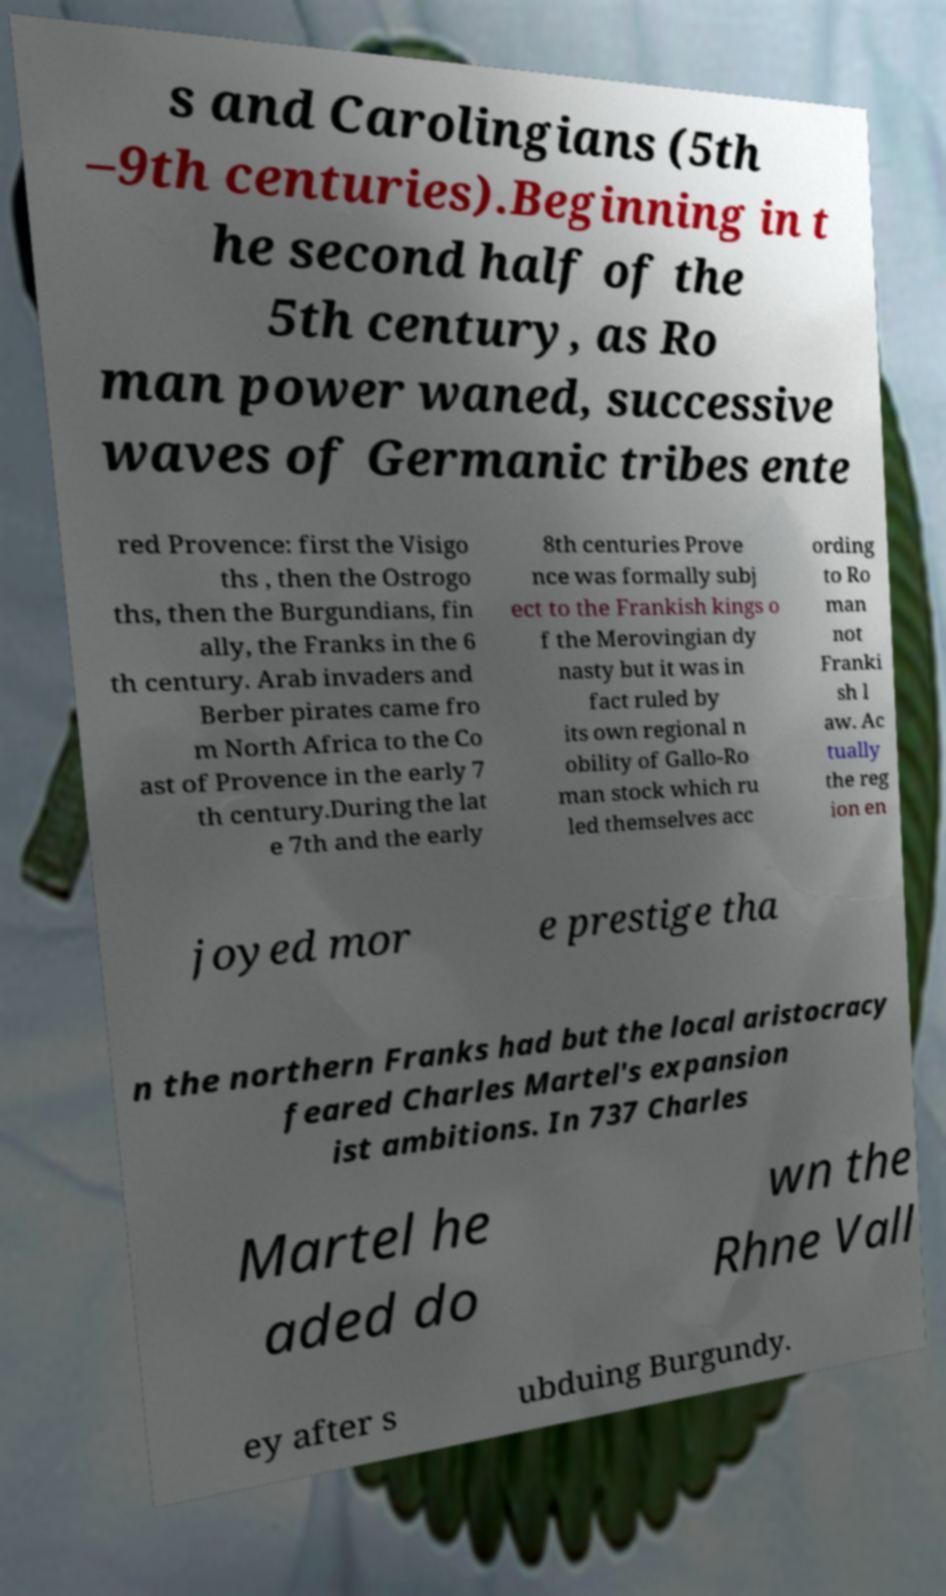There's text embedded in this image that I need extracted. Can you transcribe it verbatim? s and Carolingians (5th –9th centuries).Beginning in t he second half of the 5th century, as Ro man power waned, successive waves of Germanic tribes ente red Provence: first the Visigo ths , then the Ostrogo ths, then the Burgundians, fin ally, the Franks in the 6 th century. Arab invaders and Berber pirates came fro m North Africa to the Co ast of Provence in the early 7 th century.During the lat e 7th and the early 8th centuries Prove nce was formally subj ect to the Frankish kings o f the Merovingian dy nasty but it was in fact ruled by its own regional n obility of Gallo-Ro man stock which ru led themselves acc ording to Ro man not Franki sh l aw. Ac tually the reg ion en joyed mor e prestige tha n the northern Franks had but the local aristocracy feared Charles Martel's expansion ist ambitions. In 737 Charles Martel he aded do wn the Rhne Vall ey after s ubduing Burgundy. 